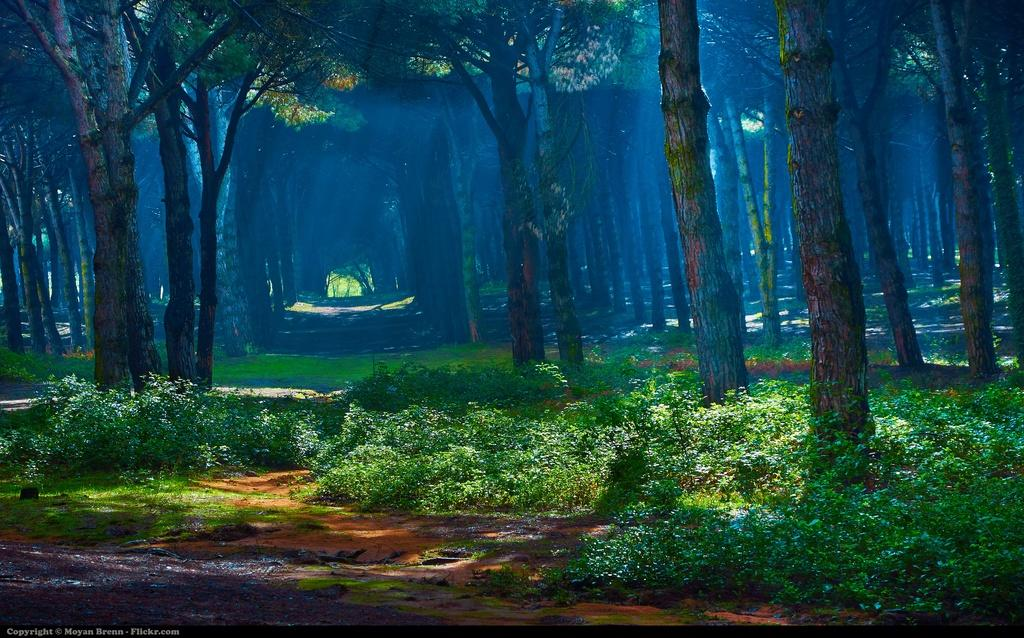What type of vegetation is present in the image? There are trees with branches and leaves in the image, as well as plants. Can you describe the trees in the image? The trees have branches and leaves. Is there any text or marking visible in the image? Yes, there is a watermark at the bottom of the image. Can you tell me how many strangers are visible in the image? There are no strangers present in the image; it features trees, plants, and a watermark. Is there any indication of pain or discomfort in the image? There is no indication of pain or discomfort in the image; it primarily focuses on the vegetation and the watermark. 